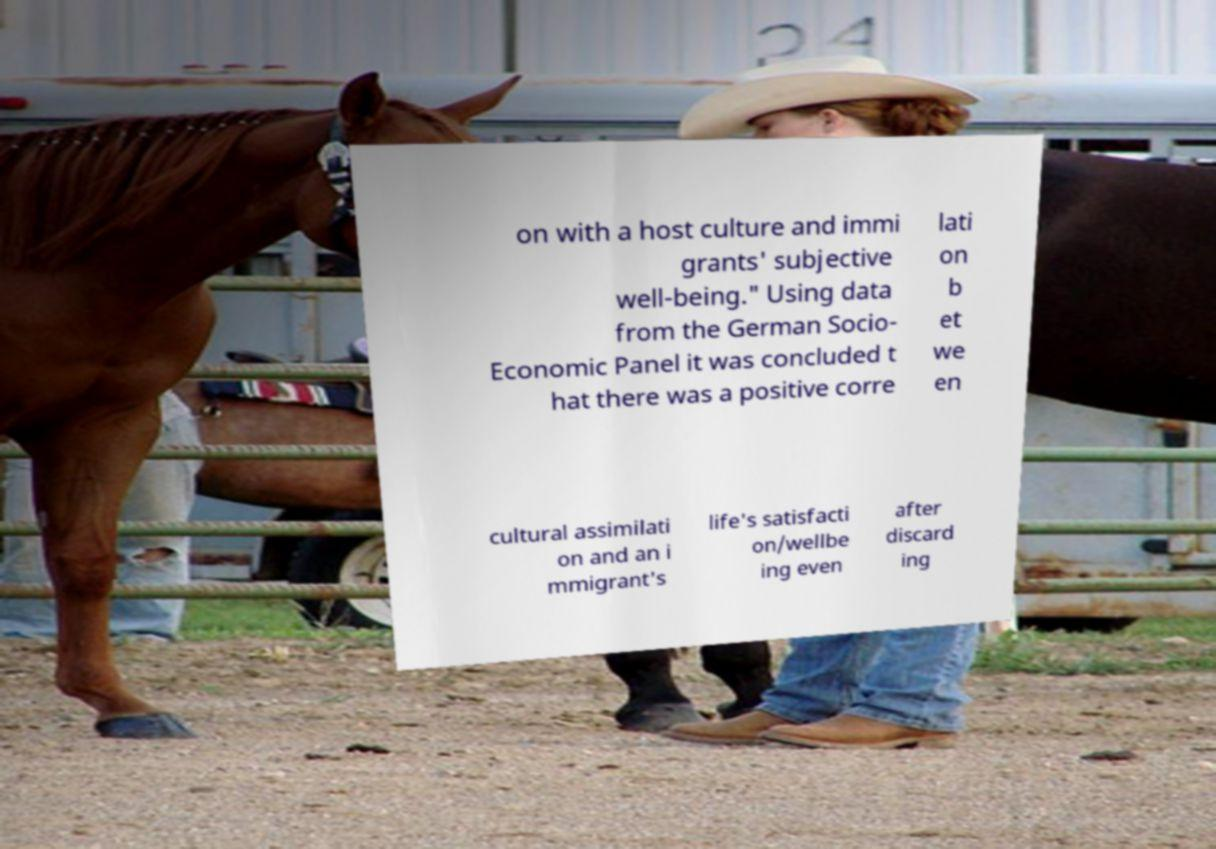What messages or text are displayed in this image? I need them in a readable, typed format. on with a host culture and immi grants' subjective well-being." Using data from the German Socio- Economic Panel it was concluded t hat there was a positive corre lati on b et we en cultural assimilati on and an i mmigrant's life's satisfacti on/wellbe ing even after discard ing 